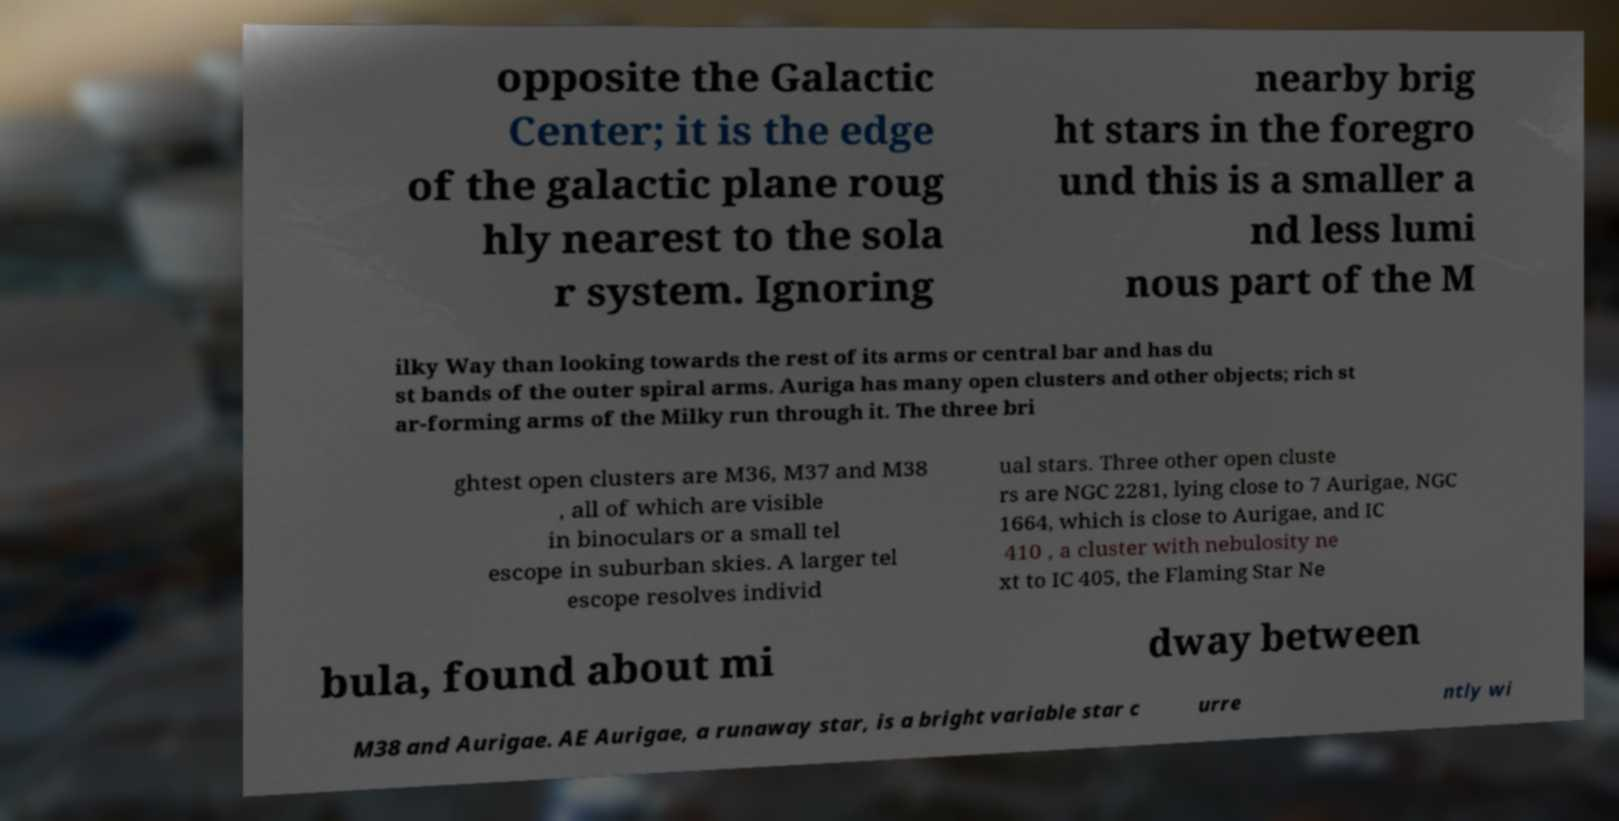There's text embedded in this image that I need extracted. Can you transcribe it verbatim? opposite the Galactic Center; it is the edge of the galactic plane roug hly nearest to the sola r system. Ignoring nearby brig ht stars in the foregro und this is a smaller a nd less lumi nous part of the M ilky Way than looking towards the rest of its arms or central bar and has du st bands of the outer spiral arms. Auriga has many open clusters and other objects; rich st ar-forming arms of the Milky run through it. The three bri ghtest open clusters are M36, M37 and M38 , all of which are visible in binoculars or a small tel escope in suburban skies. A larger tel escope resolves individ ual stars. Three other open cluste rs are NGC 2281, lying close to 7 Aurigae, NGC 1664, which is close to Aurigae, and IC 410 , a cluster with nebulosity ne xt to IC 405, the Flaming Star Ne bula, found about mi dway between M38 and Aurigae. AE Aurigae, a runaway star, is a bright variable star c urre ntly wi 